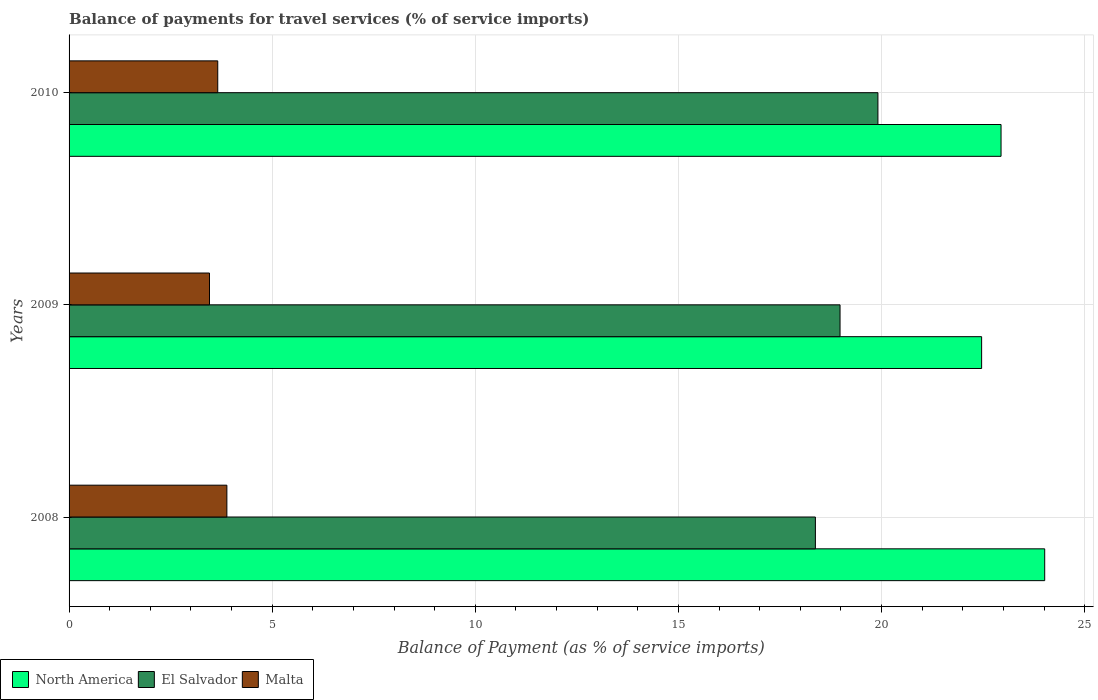How many different coloured bars are there?
Give a very brief answer. 3. How many bars are there on the 1st tick from the top?
Keep it short and to the point. 3. How many bars are there on the 3rd tick from the bottom?
Offer a very short reply. 3. What is the balance of payments for travel services in Malta in 2008?
Offer a very short reply. 3.88. Across all years, what is the maximum balance of payments for travel services in North America?
Ensure brevity in your answer.  24.01. Across all years, what is the minimum balance of payments for travel services in North America?
Keep it short and to the point. 22.46. In which year was the balance of payments for travel services in El Salvador maximum?
Provide a short and direct response. 2010. In which year was the balance of payments for travel services in North America minimum?
Offer a terse response. 2009. What is the total balance of payments for travel services in El Salvador in the graph?
Keep it short and to the point. 57.26. What is the difference between the balance of payments for travel services in Malta in 2008 and that in 2010?
Keep it short and to the point. 0.22. What is the difference between the balance of payments for travel services in North America in 2010 and the balance of payments for travel services in Malta in 2009?
Offer a terse response. 19.48. What is the average balance of payments for travel services in North America per year?
Offer a terse response. 23.14. In the year 2009, what is the difference between the balance of payments for travel services in El Salvador and balance of payments for travel services in North America?
Give a very brief answer. -3.48. In how many years, is the balance of payments for travel services in Malta greater than 4 %?
Give a very brief answer. 0. What is the ratio of the balance of payments for travel services in El Salvador in 2008 to that in 2009?
Keep it short and to the point. 0.97. What is the difference between the highest and the second highest balance of payments for travel services in El Salvador?
Offer a very short reply. 0.93. What is the difference between the highest and the lowest balance of payments for travel services in North America?
Offer a very short reply. 1.55. What does the 2nd bar from the top in 2010 represents?
Your answer should be very brief. El Salvador. What does the 1st bar from the bottom in 2010 represents?
Ensure brevity in your answer.  North America. Is it the case that in every year, the sum of the balance of payments for travel services in Malta and balance of payments for travel services in El Salvador is greater than the balance of payments for travel services in North America?
Offer a terse response. No. How many bars are there?
Provide a succinct answer. 9. What is the title of the graph?
Your answer should be very brief. Balance of payments for travel services (% of service imports). Does "Djibouti" appear as one of the legend labels in the graph?
Provide a succinct answer. No. What is the label or title of the X-axis?
Your answer should be compact. Balance of Payment (as % of service imports). What is the label or title of the Y-axis?
Provide a succinct answer. Years. What is the Balance of Payment (as % of service imports) of North America in 2008?
Provide a succinct answer. 24.01. What is the Balance of Payment (as % of service imports) of El Salvador in 2008?
Your answer should be compact. 18.37. What is the Balance of Payment (as % of service imports) of Malta in 2008?
Your answer should be very brief. 3.88. What is the Balance of Payment (as % of service imports) of North America in 2009?
Keep it short and to the point. 22.46. What is the Balance of Payment (as % of service imports) of El Salvador in 2009?
Make the answer very short. 18.98. What is the Balance of Payment (as % of service imports) in Malta in 2009?
Provide a succinct answer. 3.46. What is the Balance of Payment (as % of service imports) in North America in 2010?
Your answer should be compact. 22.94. What is the Balance of Payment (as % of service imports) of El Salvador in 2010?
Ensure brevity in your answer.  19.91. What is the Balance of Payment (as % of service imports) in Malta in 2010?
Your answer should be very brief. 3.66. Across all years, what is the maximum Balance of Payment (as % of service imports) in North America?
Keep it short and to the point. 24.01. Across all years, what is the maximum Balance of Payment (as % of service imports) in El Salvador?
Ensure brevity in your answer.  19.91. Across all years, what is the maximum Balance of Payment (as % of service imports) of Malta?
Make the answer very short. 3.88. Across all years, what is the minimum Balance of Payment (as % of service imports) of North America?
Provide a short and direct response. 22.46. Across all years, what is the minimum Balance of Payment (as % of service imports) in El Salvador?
Your answer should be compact. 18.37. Across all years, what is the minimum Balance of Payment (as % of service imports) of Malta?
Make the answer very short. 3.46. What is the total Balance of Payment (as % of service imports) of North America in the graph?
Your answer should be very brief. 69.42. What is the total Balance of Payment (as % of service imports) in El Salvador in the graph?
Your response must be concise. 57.26. What is the total Balance of Payment (as % of service imports) in Malta in the graph?
Provide a succinct answer. 11. What is the difference between the Balance of Payment (as % of service imports) in North America in 2008 and that in 2009?
Provide a short and direct response. 1.55. What is the difference between the Balance of Payment (as % of service imports) in El Salvador in 2008 and that in 2009?
Your response must be concise. -0.61. What is the difference between the Balance of Payment (as % of service imports) in Malta in 2008 and that in 2009?
Offer a very short reply. 0.43. What is the difference between the Balance of Payment (as % of service imports) of North America in 2008 and that in 2010?
Your answer should be compact. 1.07. What is the difference between the Balance of Payment (as % of service imports) in El Salvador in 2008 and that in 2010?
Provide a short and direct response. -1.54. What is the difference between the Balance of Payment (as % of service imports) of Malta in 2008 and that in 2010?
Provide a succinct answer. 0.22. What is the difference between the Balance of Payment (as % of service imports) in North America in 2009 and that in 2010?
Your response must be concise. -0.48. What is the difference between the Balance of Payment (as % of service imports) of El Salvador in 2009 and that in 2010?
Ensure brevity in your answer.  -0.93. What is the difference between the Balance of Payment (as % of service imports) in Malta in 2009 and that in 2010?
Your response must be concise. -0.2. What is the difference between the Balance of Payment (as % of service imports) of North America in 2008 and the Balance of Payment (as % of service imports) of El Salvador in 2009?
Keep it short and to the point. 5.04. What is the difference between the Balance of Payment (as % of service imports) of North America in 2008 and the Balance of Payment (as % of service imports) of Malta in 2009?
Provide a succinct answer. 20.56. What is the difference between the Balance of Payment (as % of service imports) in El Salvador in 2008 and the Balance of Payment (as % of service imports) in Malta in 2009?
Provide a succinct answer. 14.91. What is the difference between the Balance of Payment (as % of service imports) of North America in 2008 and the Balance of Payment (as % of service imports) of El Salvador in 2010?
Provide a succinct answer. 4.11. What is the difference between the Balance of Payment (as % of service imports) of North America in 2008 and the Balance of Payment (as % of service imports) of Malta in 2010?
Your answer should be very brief. 20.35. What is the difference between the Balance of Payment (as % of service imports) of El Salvador in 2008 and the Balance of Payment (as % of service imports) of Malta in 2010?
Offer a terse response. 14.71. What is the difference between the Balance of Payment (as % of service imports) in North America in 2009 and the Balance of Payment (as % of service imports) in El Salvador in 2010?
Give a very brief answer. 2.55. What is the difference between the Balance of Payment (as % of service imports) in North America in 2009 and the Balance of Payment (as % of service imports) in Malta in 2010?
Your answer should be very brief. 18.8. What is the difference between the Balance of Payment (as % of service imports) in El Salvador in 2009 and the Balance of Payment (as % of service imports) in Malta in 2010?
Make the answer very short. 15.32. What is the average Balance of Payment (as % of service imports) of North America per year?
Offer a very short reply. 23.14. What is the average Balance of Payment (as % of service imports) of El Salvador per year?
Your answer should be very brief. 19.09. What is the average Balance of Payment (as % of service imports) in Malta per year?
Your answer should be very brief. 3.67. In the year 2008, what is the difference between the Balance of Payment (as % of service imports) of North America and Balance of Payment (as % of service imports) of El Salvador?
Your answer should be compact. 5.64. In the year 2008, what is the difference between the Balance of Payment (as % of service imports) of North America and Balance of Payment (as % of service imports) of Malta?
Offer a terse response. 20.13. In the year 2008, what is the difference between the Balance of Payment (as % of service imports) in El Salvador and Balance of Payment (as % of service imports) in Malta?
Your answer should be compact. 14.49. In the year 2009, what is the difference between the Balance of Payment (as % of service imports) of North America and Balance of Payment (as % of service imports) of El Salvador?
Provide a succinct answer. 3.48. In the year 2009, what is the difference between the Balance of Payment (as % of service imports) in North America and Balance of Payment (as % of service imports) in Malta?
Offer a terse response. 19.01. In the year 2009, what is the difference between the Balance of Payment (as % of service imports) in El Salvador and Balance of Payment (as % of service imports) in Malta?
Offer a very short reply. 15.52. In the year 2010, what is the difference between the Balance of Payment (as % of service imports) of North America and Balance of Payment (as % of service imports) of El Salvador?
Your response must be concise. 3.03. In the year 2010, what is the difference between the Balance of Payment (as % of service imports) in North America and Balance of Payment (as % of service imports) in Malta?
Give a very brief answer. 19.28. In the year 2010, what is the difference between the Balance of Payment (as % of service imports) in El Salvador and Balance of Payment (as % of service imports) in Malta?
Offer a very short reply. 16.25. What is the ratio of the Balance of Payment (as % of service imports) in North America in 2008 to that in 2009?
Give a very brief answer. 1.07. What is the ratio of the Balance of Payment (as % of service imports) in Malta in 2008 to that in 2009?
Ensure brevity in your answer.  1.12. What is the ratio of the Balance of Payment (as % of service imports) of North America in 2008 to that in 2010?
Provide a succinct answer. 1.05. What is the ratio of the Balance of Payment (as % of service imports) of El Salvador in 2008 to that in 2010?
Make the answer very short. 0.92. What is the ratio of the Balance of Payment (as % of service imports) of Malta in 2008 to that in 2010?
Make the answer very short. 1.06. What is the ratio of the Balance of Payment (as % of service imports) of North America in 2009 to that in 2010?
Provide a short and direct response. 0.98. What is the ratio of the Balance of Payment (as % of service imports) of El Salvador in 2009 to that in 2010?
Provide a short and direct response. 0.95. What is the ratio of the Balance of Payment (as % of service imports) of Malta in 2009 to that in 2010?
Give a very brief answer. 0.94. What is the difference between the highest and the second highest Balance of Payment (as % of service imports) of North America?
Provide a short and direct response. 1.07. What is the difference between the highest and the second highest Balance of Payment (as % of service imports) in El Salvador?
Your response must be concise. 0.93. What is the difference between the highest and the second highest Balance of Payment (as % of service imports) in Malta?
Your response must be concise. 0.22. What is the difference between the highest and the lowest Balance of Payment (as % of service imports) of North America?
Your response must be concise. 1.55. What is the difference between the highest and the lowest Balance of Payment (as % of service imports) in El Salvador?
Provide a succinct answer. 1.54. What is the difference between the highest and the lowest Balance of Payment (as % of service imports) of Malta?
Your response must be concise. 0.43. 